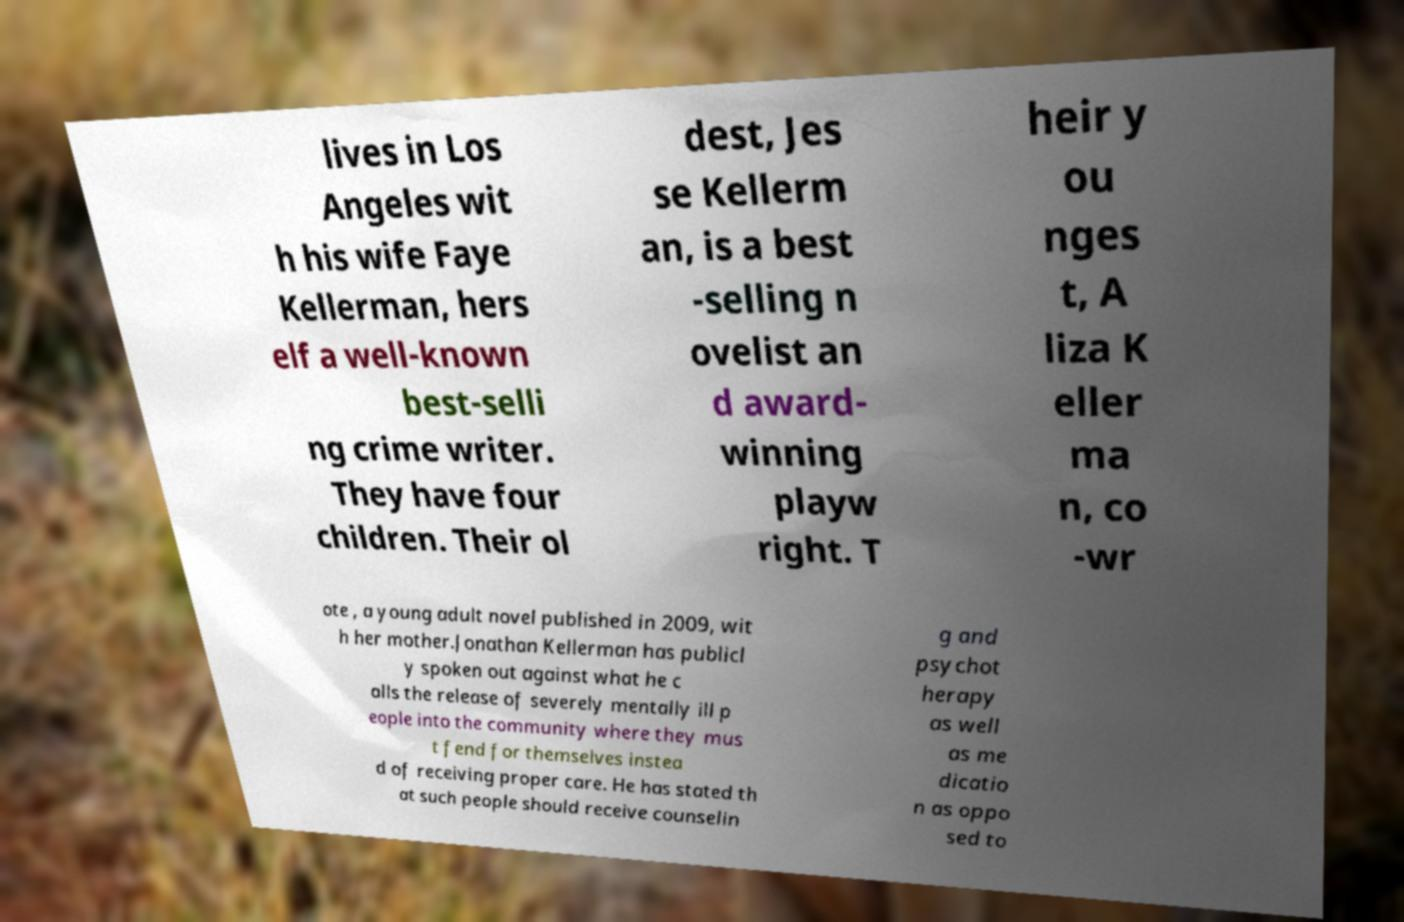Could you assist in decoding the text presented in this image and type it out clearly? lives in Los Angeles wit h his wife Faye Kellerman, hers elf a well-known best-selli ng crime writer. They have four children. Their ol dest, Jes se Kellerm an, is a best -selling n ovelist an d award- winning playw right. T heir y ou nges t, A liza K eller ma n, co -wr ote , a young adult novel published in 2009, wit h her mother.Jonathan Kellerman has publicl y spoken out against what he c alls the release of severely mentally ill p eople into the community where they mus t fend for themselves instea d of receiving proper care. He has stated th at such people should receive counselin g and psychot herapy as well as me dicatio n as oppo sed to 